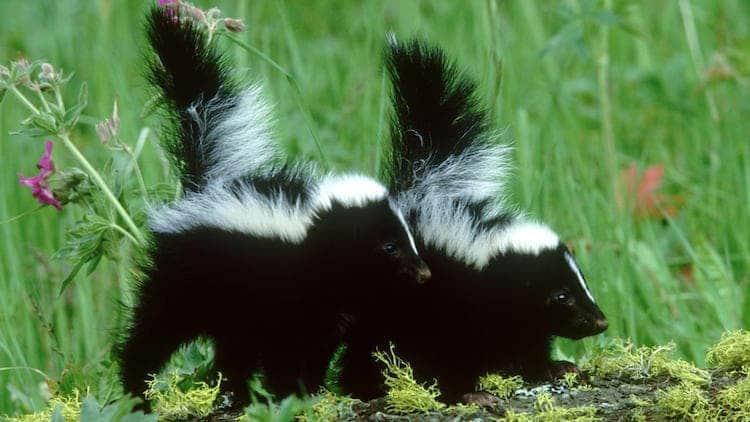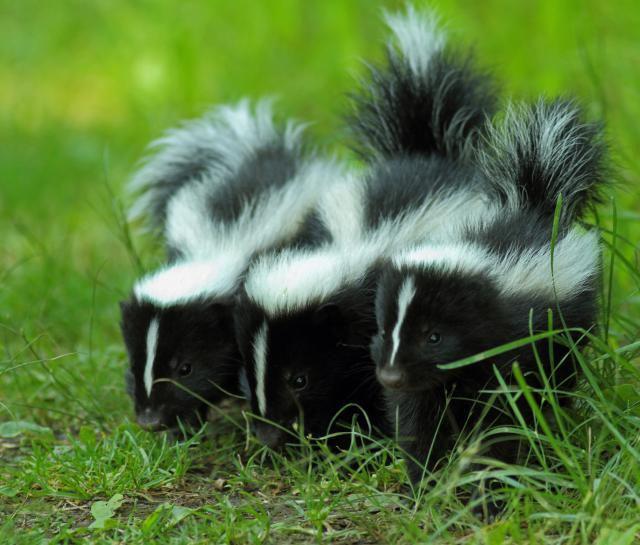The first image is the image on the left, the second image is the image on the right. For the images displayed, is the sentence "In at least one image there is a single skunk facing left." factually correct? Answer yes or no. No. The first image is the image on the left, the second image is the image on the right. For the images displayed, is the sentence "There is a single skunk in the right image." factually correct? Answer yes or no. No. 